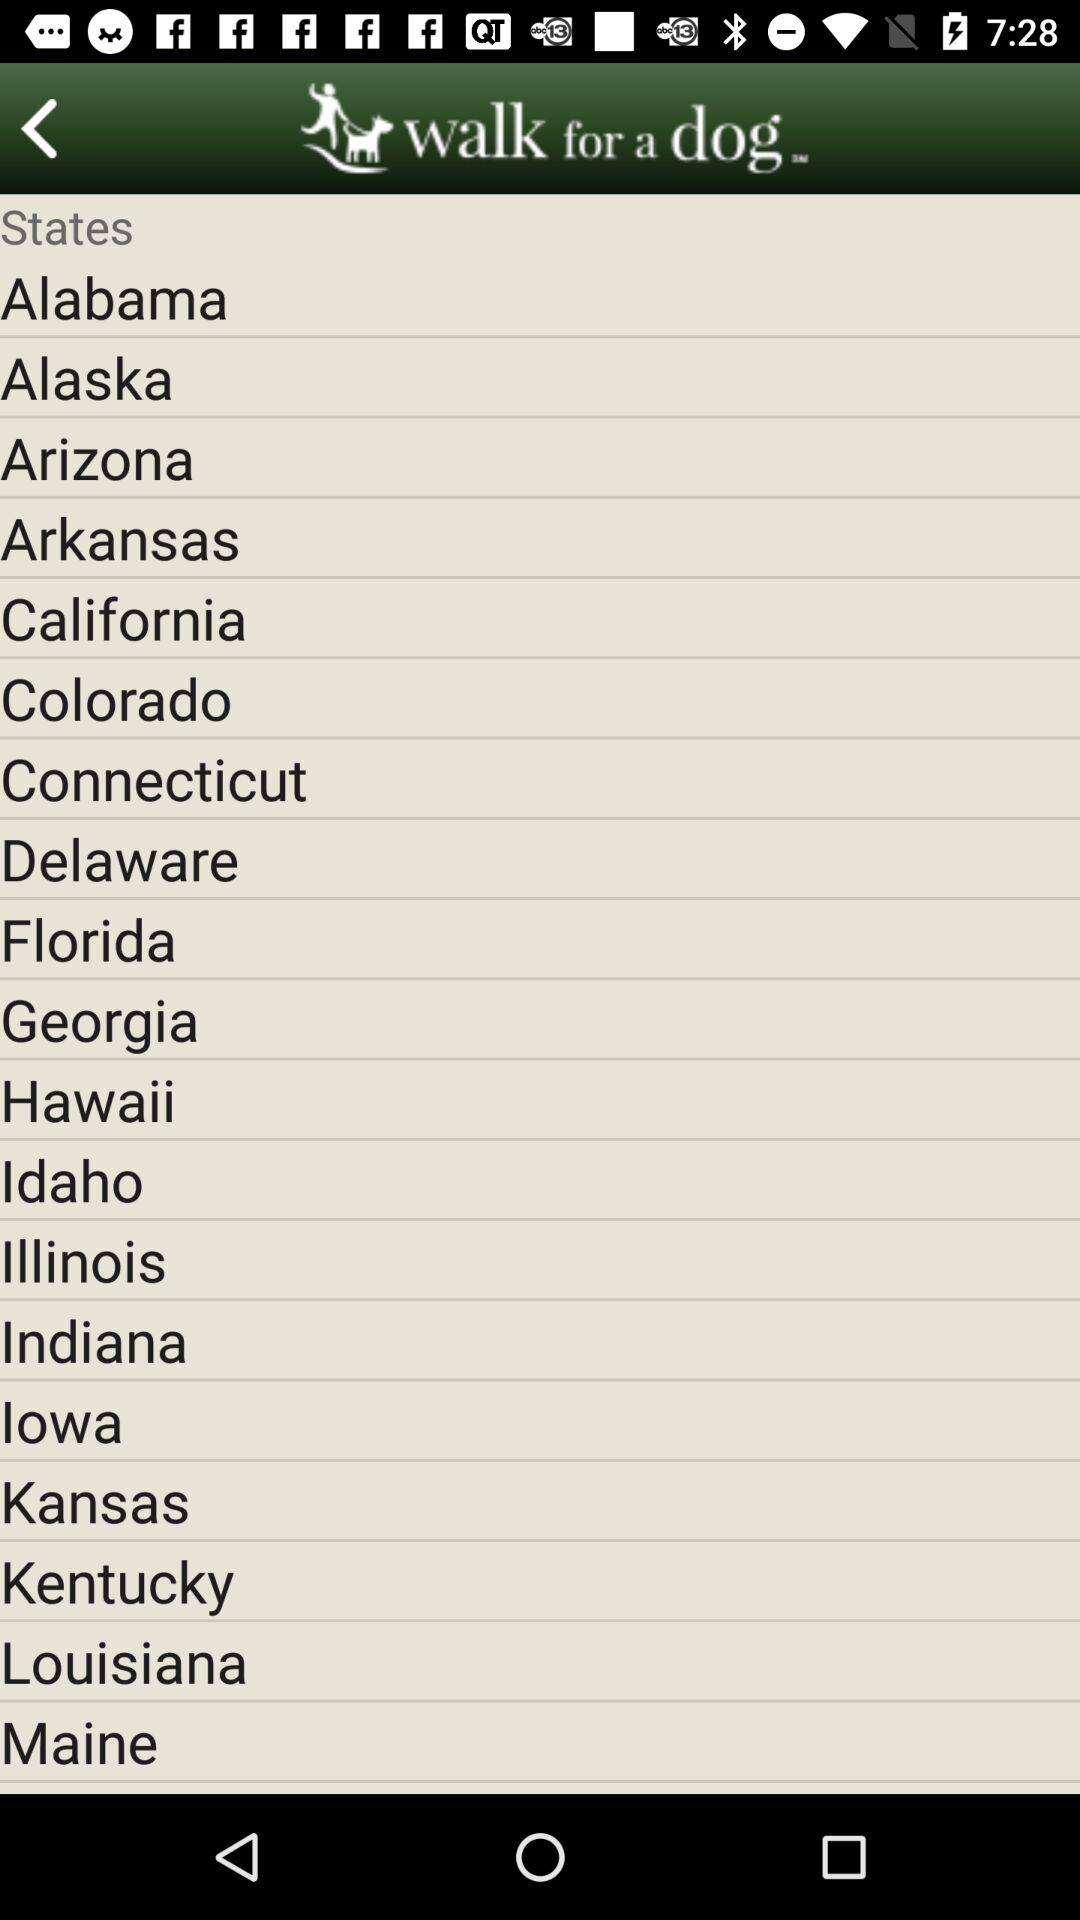What are the different states that are available? The different available states are "Alabama", "Alaska", "Arizona", "Arkansas", "California", "Colorado", "Connecticut", "Delaware", "Florida", "Georgia", "Hawaii", "Idaho", "Illinois", "Indiana", "lowa", "Kansas", "Kentucky", "Louisiana", and "Maine". 